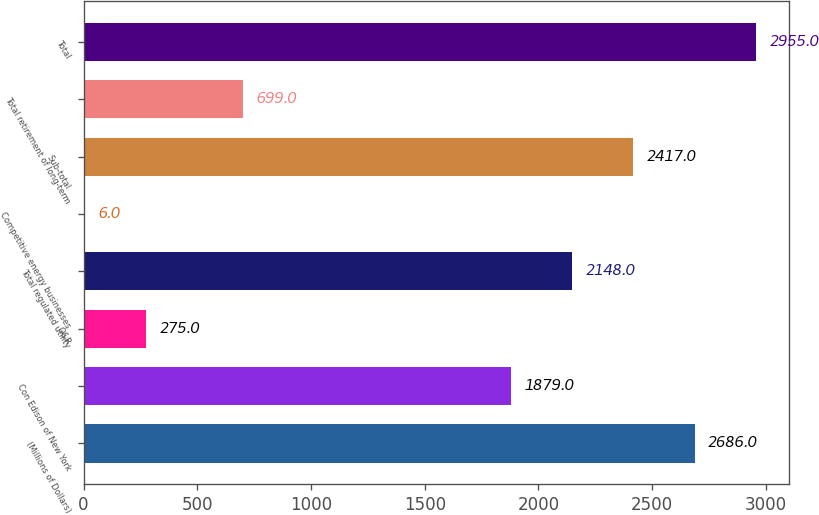<chart> <loc_0><loc_0><loc_500><loc_500><bar_chart><fcel>(Millions of Dollars)<fcel>Con Edison of New York<fcel>O&R<fcel>Total regulated utility<fcel>Competitive energy businesses<fcel>Sub-total<fcel>Total retirement of long-term<fcel>Total<nl><fcel>2686<fcel>1879<fcel>275<fcel>2148<fcel>6<fcel>2417<fcel>699<fcel>2955<nl></chart> 